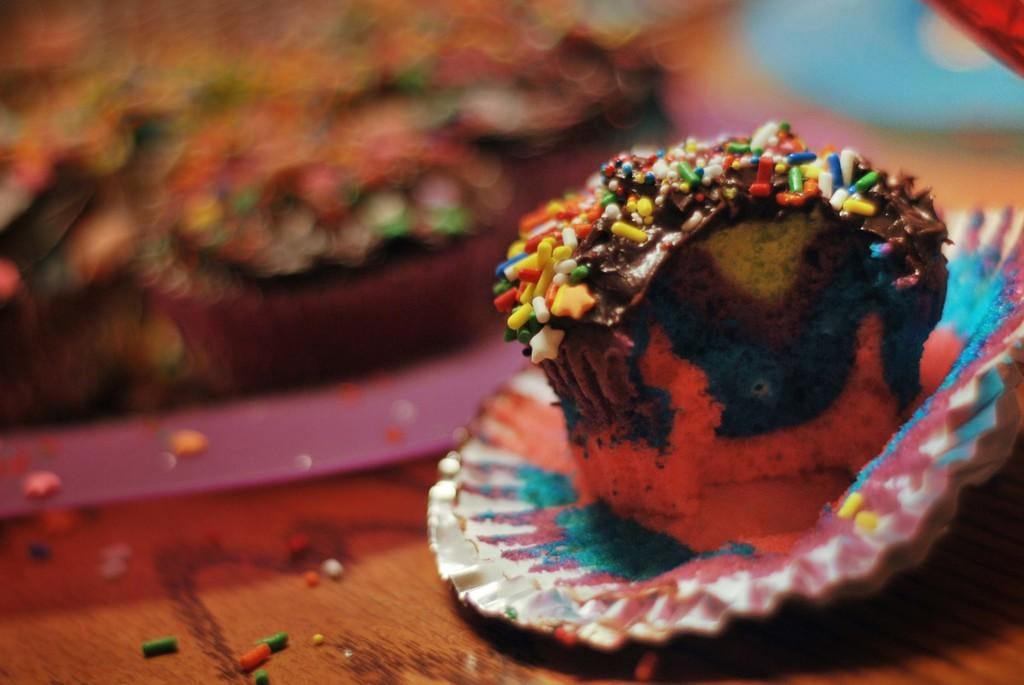What is the main subject of the image? There is a cupcake in the image. Where is the cupcake located? The cupcake is on a table. What else can be seen in the image besides the cupcake? There is a wrapper in the image. Can you describe the cupcake's appearance? The cupcake has stuffing. How would you describe the background of the image? The background of the image is blurred. What type of gold can be seen on the island in the image? There is no gold or island present in the image; it features a cupcake on a table. What is the source of fear in the image? There is no fear or indication of fear in the image; it simply shows a cupcake on a table. 